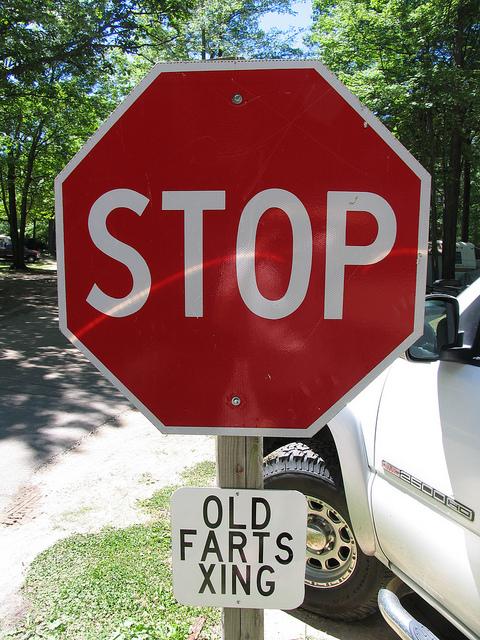What does XING mean?
Keep it brief. Crossing. What does the red sign at the top say?
Concise answer only. Stop. What does the bottom sign say?
Write a very short answer. Old farts xing. 